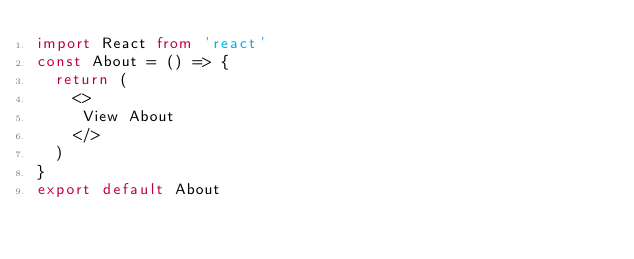<code> <loc_0><loc_0><loc_500><loc_500><_TypeScript_>import React from 'react'
const About = () => {
  return (
    <>
     View About
    </>
  )
}
export default About</code> 